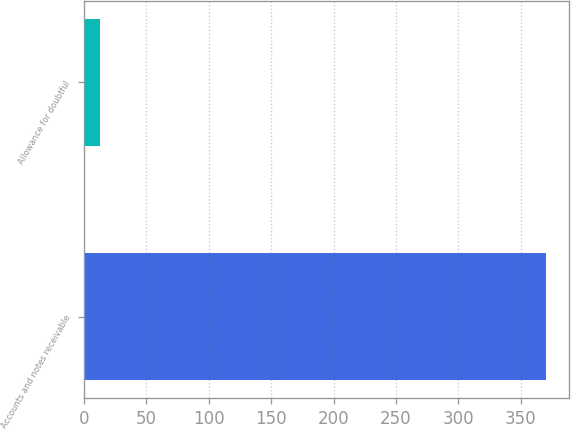Convert chart to OTSL. <chart><loc_0><loc_0><loc_500><loc_500><bar_chart><fcel>Accounts and notes receivable<fcel>Allowance for doubtful<nl><fcel>370<fcel>13<nl></chart> 